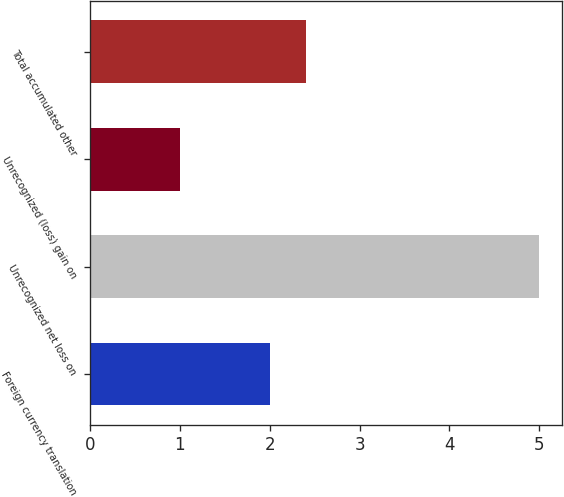Convert chart. <chart><loc_0><loc_0><loc_500><loc_500><bar_chart><fcel>Foreign currency translation<fcel>Unrecognized net loss on<fcel>Unrecognized (loss) gain on<fcel>Total accumulated other<nl><fcel>2<fcel>5<fcel>1<fcel>2.4<nl></chart> 